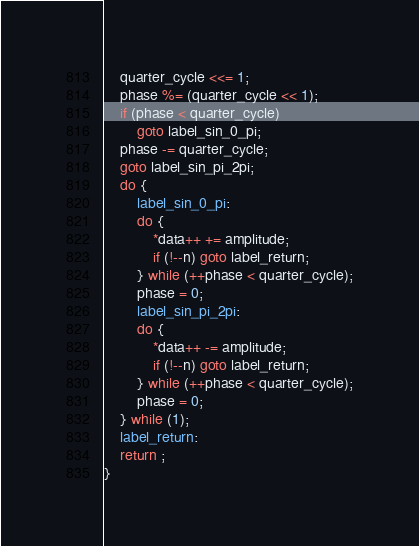Convert code to text. <code><loc_0><loc_0><loc_500><loc_500><_C_>	quarter_cycle <<= 1;
	phase %= (quarter_cycle << 1);
	if (phase < quarter_cycle)
		goto label_sin_0_pi;
	phase -= quarter_cycle;
	goto label_sin_pi_2pi;
	do {
		label_sin_0_pi:
		do {
			*data++ += amplitude;
			if (!--n) goto label_return;
		} while (++phase < quarter_cycle);
		phase = 0;
		label_sin_pi_2pi:
		do {
			*data++ -= amplitude;
			if (!--n) goto label_return;
		} while (++phase < quarter_cycle);
		phase = 0;
	} while (1);
	label_return:
	return ;
}
</code> 